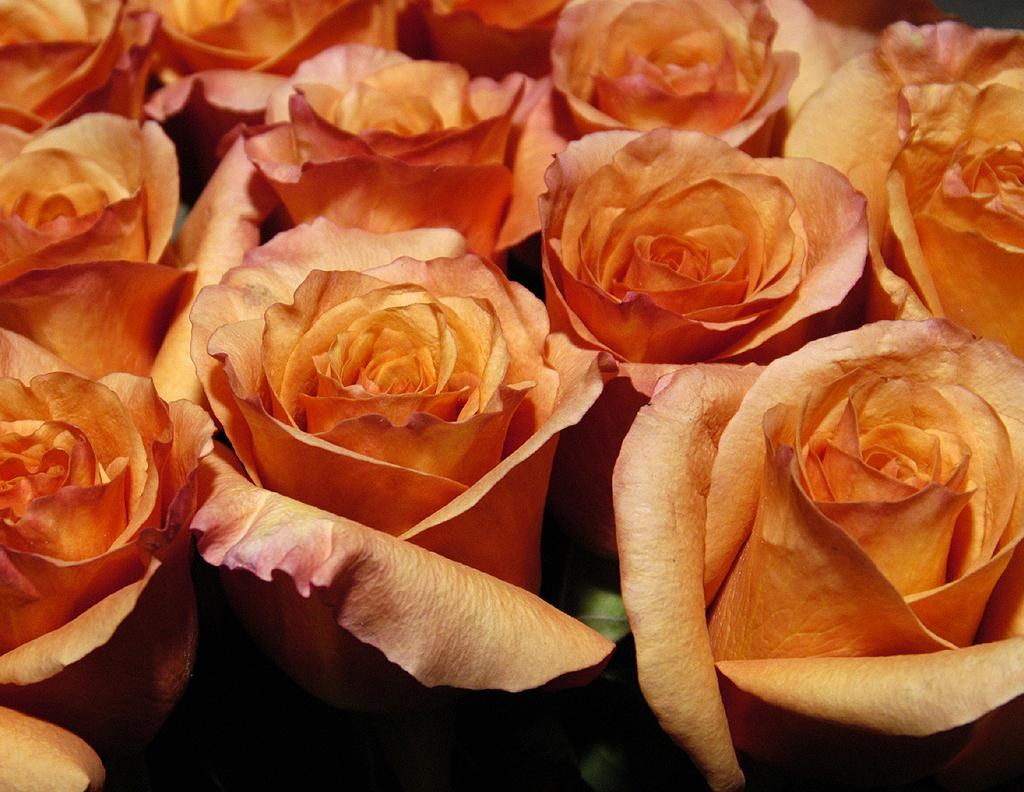What type of flowers are present in the image? There is a bunch of roses in the image. Can you describe the arrangement of the flowers? The roses are arranged in a bunch. What might the roses be used for? The roses might be used for decoration or as a gift. What type of education can be seen in the image? There is no reference to education in the image; it features a bunch of roses. How many rings are visible on the roses in the image? There are no rings present on the roses in the image. 